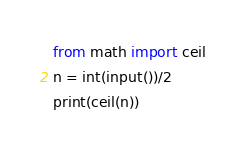Convert code to text. <code><loc_0><loc_0><loc_500><loc_500><_Python_>from math import ceil
n = int(input())/2
print(ceil(n))</code> 